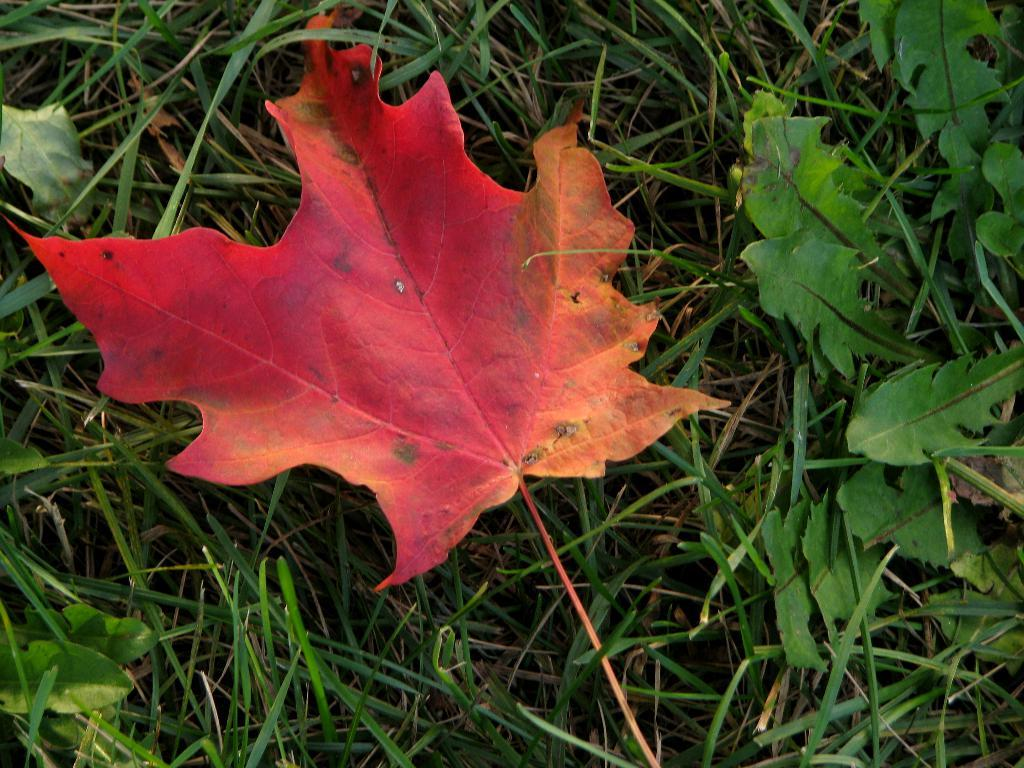What type of vegetation can be seen in the image? There are leaves and grass in the image. Can you describe the natural environment depicted in the image? The image features leaves and grass, which suggests a natural, outdoor setting. What is the expert's opinion on the taste of the leaves in the image? There is no expert present in the image, and no information is provided about the taste of the leaves. 